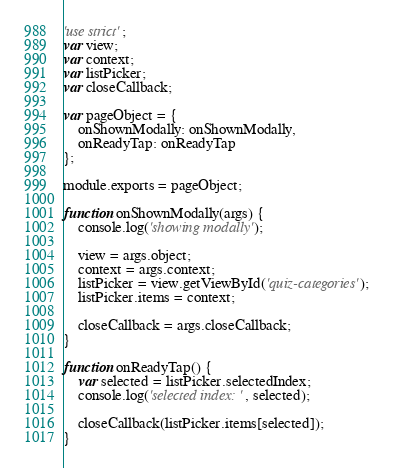<code> <loc_0><loc_0><loc_500><loc_500><_JavaScript_>'use strict';
var view;
var context;
var listPicker;
var closeCallback;

var pageObject = {
    onShownModally: onShownModally,
    onReadyTap: onReadyTap
};

module.exports = pageObject;

function onShownModally(args) {
    console.log('showing modally');

    view = args.object;
    context = args.context;
    listPicker = view.getViewById('quiz-categories');
    listPicker.items = context;

    closeCallback = args.closeCallback;
}

function onReadyTap() {
    var selected = listPicker.selectedIndex;
    console.log('selected index: ', selected);

    closeCallback(listPicker.items[selected]);
}</code> 